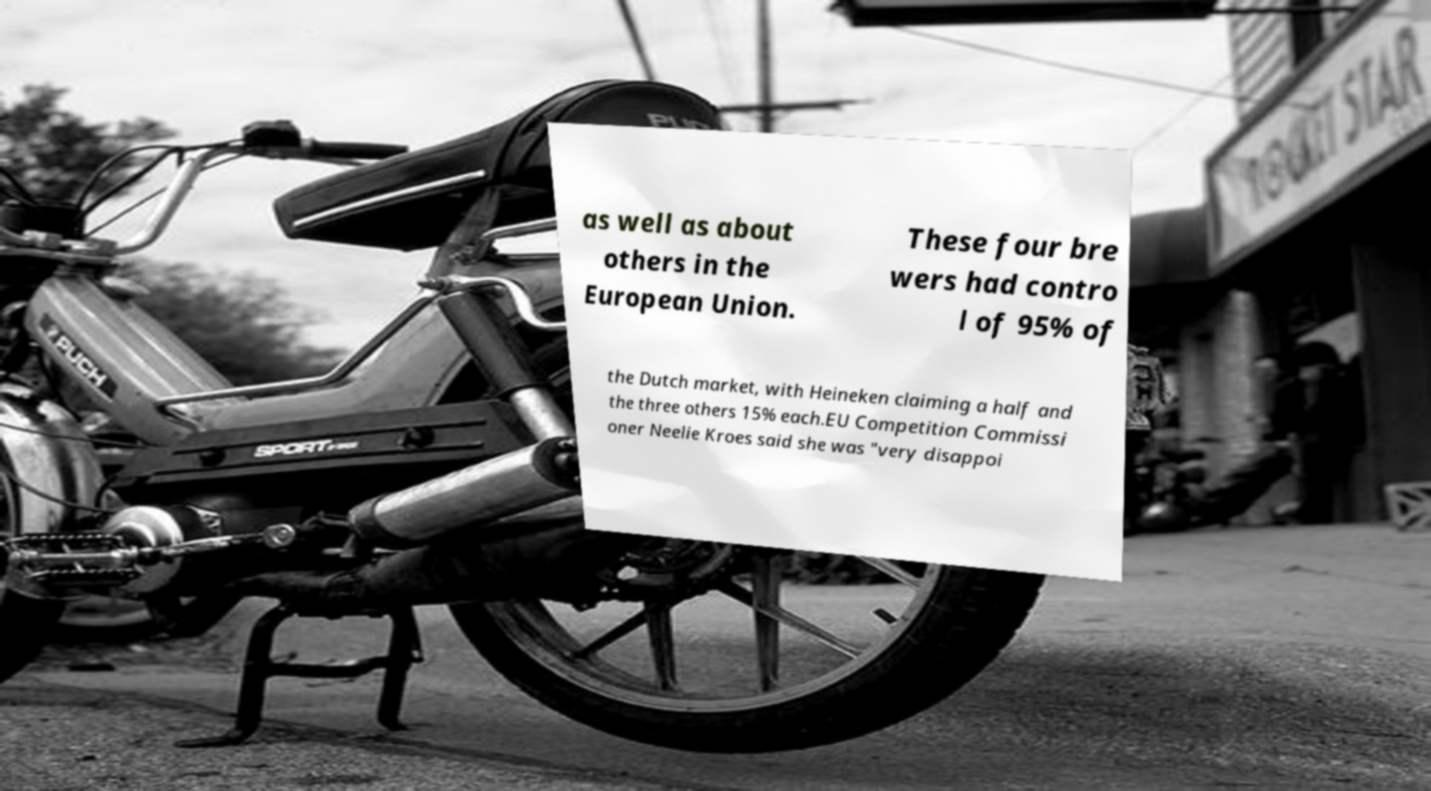I need the written content from this picture converted into text. Can you do that? as well as about others in the European Union. These four bre wers had contro l of 95% of the Dutch market, with Heineken claiming a half and the three others 15% each.EU Competition Commissi oner Neelie Kroes said she was "very disappoi 